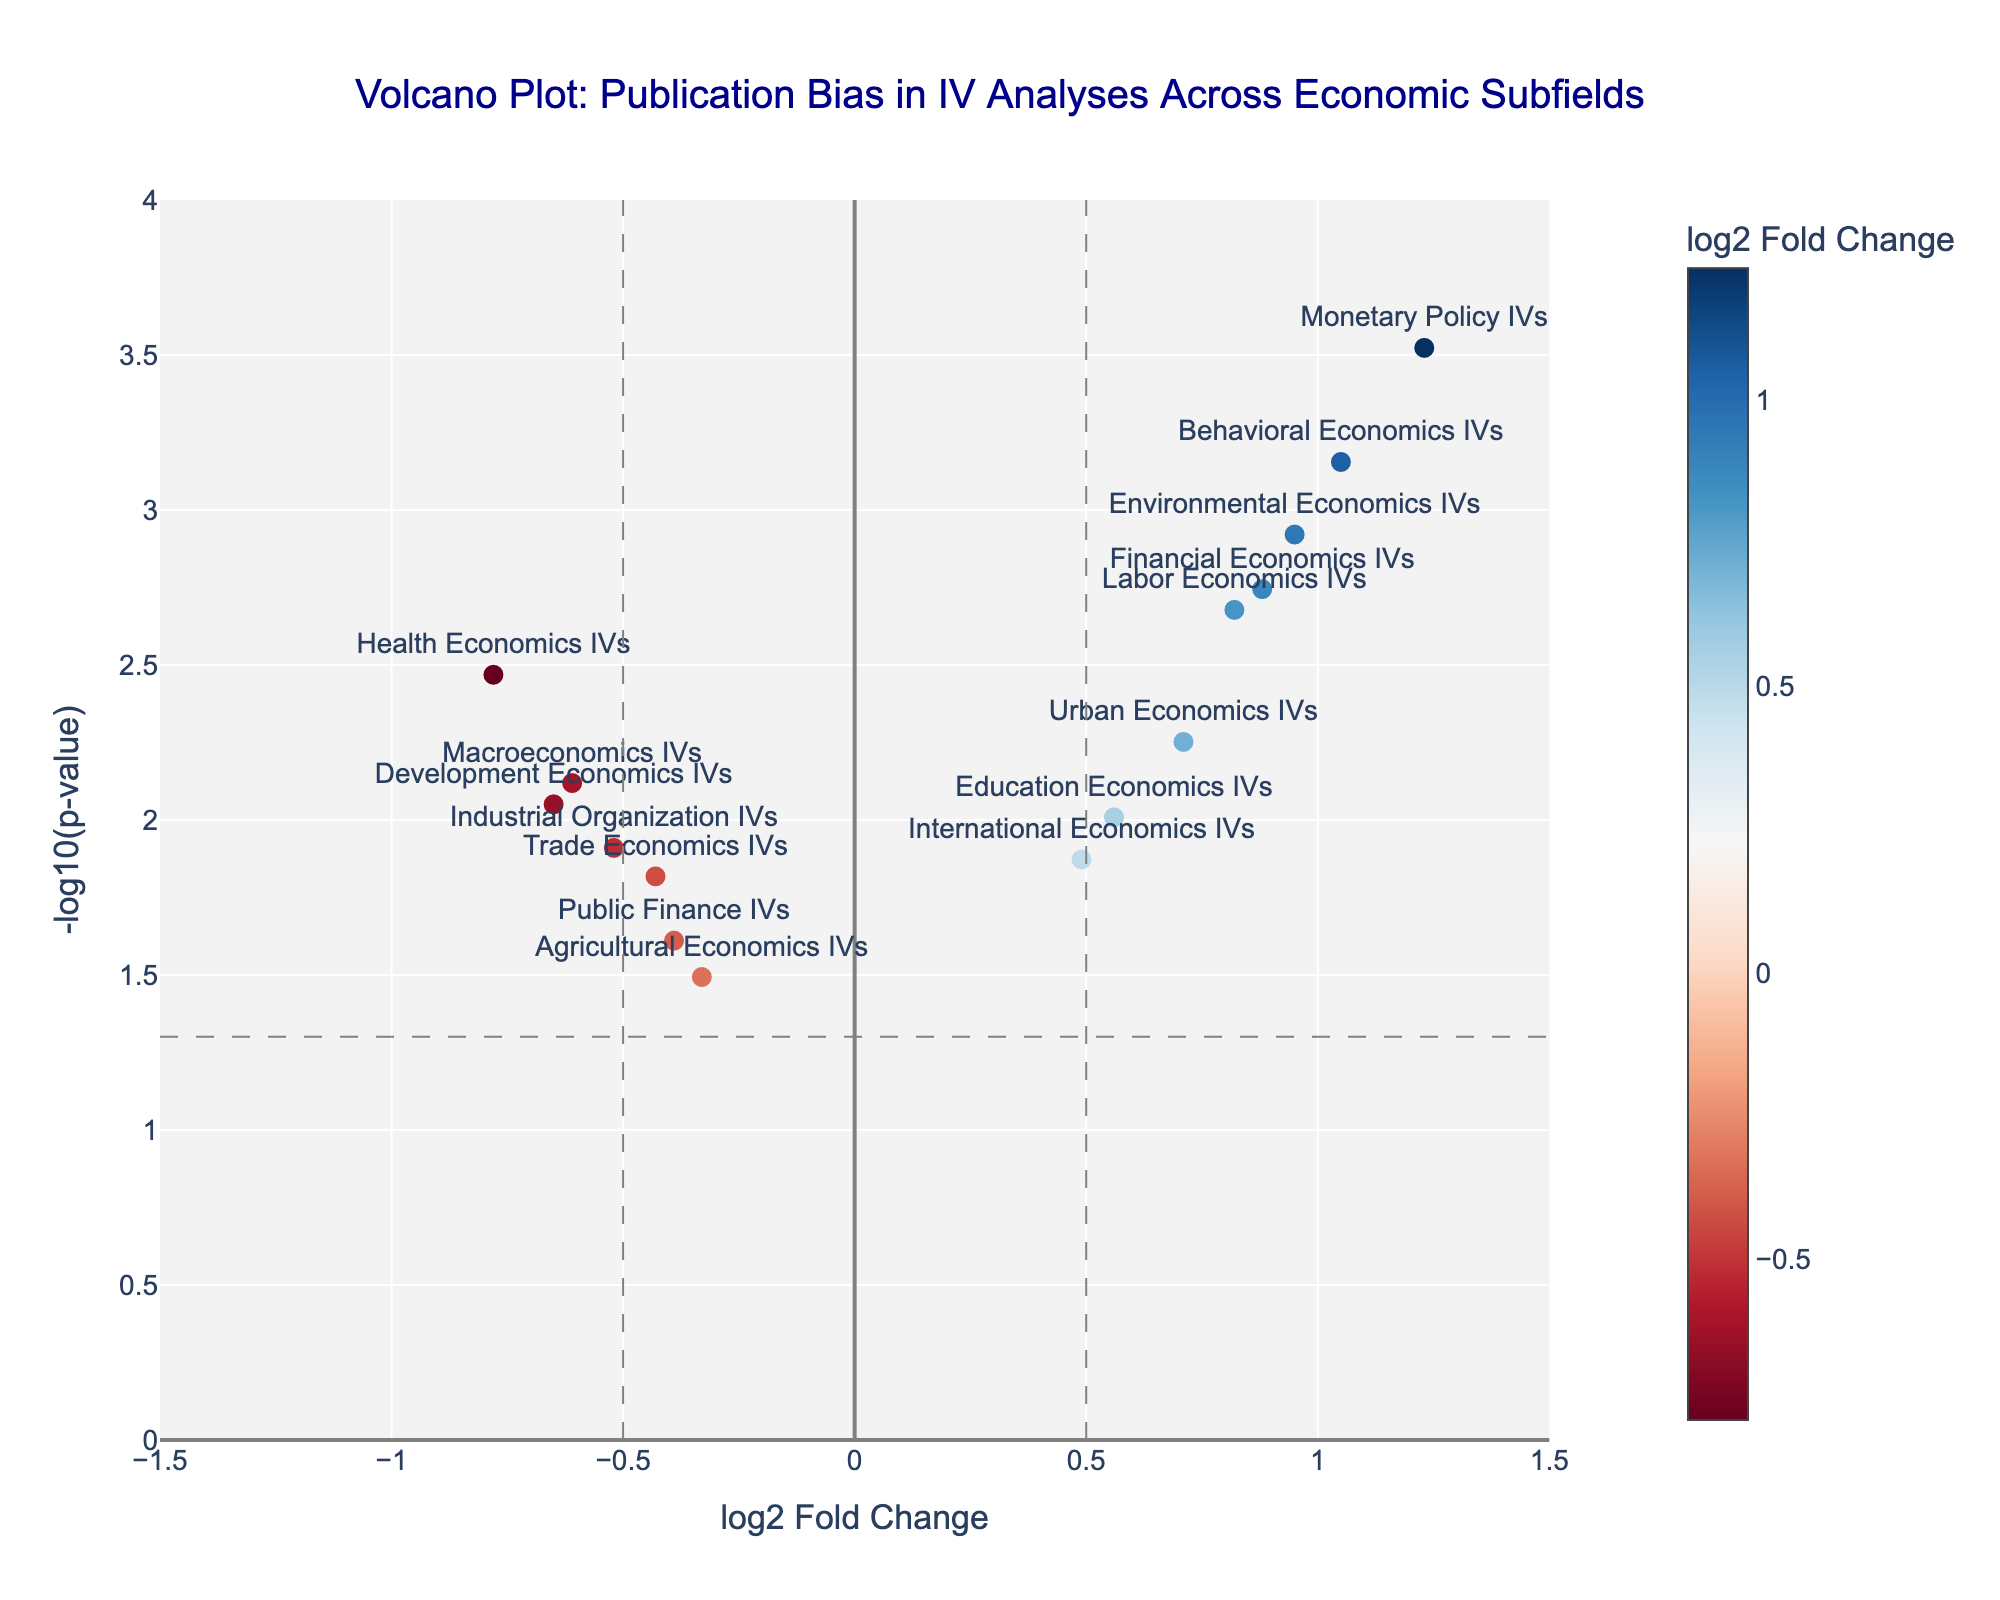what is the title of the plot? The title is located at the top of the figure, and it provides the main information about what is being displayed in the plot.
Answer: Volcano Plot: Publication Bias in IV Analyses Across Economic Subfields How many studies have a significant p-value (p < 0.05)? Studies with p-values less than 0.05 are above the horizontal dashed line at y = -log10(0.05). Count the dots above this line.
Answer: 14 Which economic subfield has the highest log2 fold change? Look for the data point farthest to the right on the x-axis, which represents the highest log2 fold change.
Answer: Monetary Policy IVs What is the p-value threshold represented by the horizontal dashed line? The horizontal dashed line intersects the y-axis at the point where -log10(p-value) equals a common threshold. This threshold is usually set at 0.05.
Answer: 0.05 How many studies have a negative log2 fold change? Count the number of data points positioned to the left of zero on the x-axis, indicating negative log2 fold change.
Answer: 7 Which study has the smallest p-value? Find the data point at the highest y-coordinate because -log10(p-value) is highest when the p-value is smallest.
Answer: Monetary Policy IVs Which economic subfield has the most positive impact, and how do you know? The most positive impact is represented by the highest log2 fold change. Look for the point farthest to the right on the x-axis.
Answer: Monetary Policy IVs Compare the log2 fold changes of Labor Economics IVs and Health Economics IVs. Which has a higher value? Locate the data points for both subfields and compare their positions on the x-axis. The one farther to the right has a higher log2 fold change.
Answer: Labor Economics IVs What’s the difference between the log2 fold change values of Environmental Economics IVs and Urban Economics IVs? Find the x-coordinates of the points labeled Environmental Economics IVs and Urban Economics IVs, then subtract the smaller value from the larger one.
Answer: 0.24 Which study has the closest p-value to 0.01? Identify the data points around the -log10(0.01) line, which is equal to 2 on the y-axis, and find the one closest to it.
Answer: Education Economics IVs 